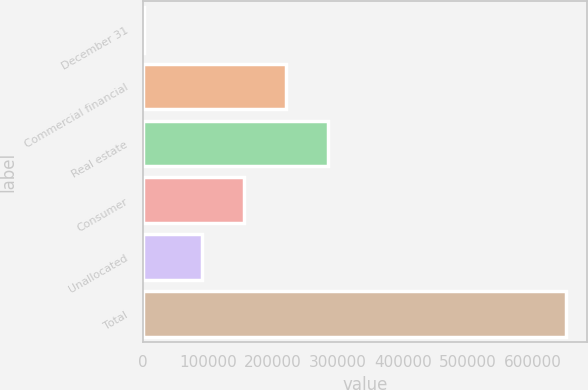<chart> <loc_0><loc_0><loc_500><loc_500><bar_chart><fcel>December 31<fcel>Commercial financial<fcel>Real estate<fcel>Consumer<fcel>Unallocated<fcel>Total<nl><fcel>2006<fcel>220169<fcel>284964<fcel>155375<fcel>90581<fcel>649948<nl></chart> 